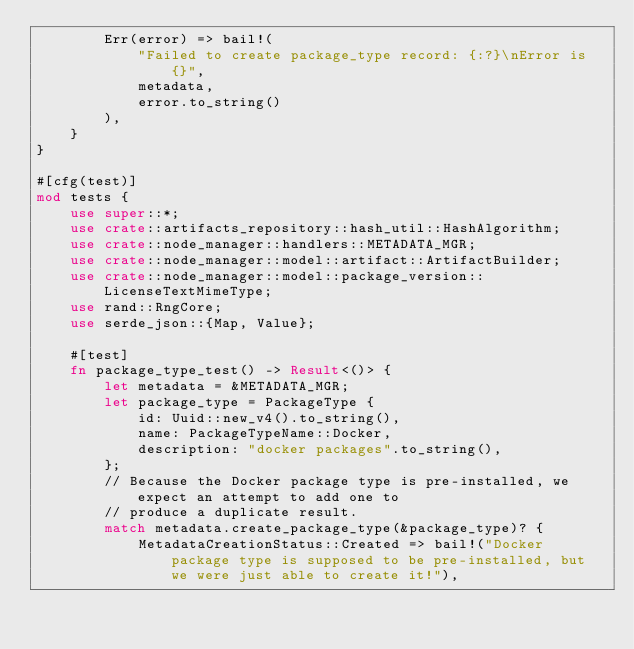Convert code to text. <code><loc_0><loc_0><loc_500><loc_500><_Rust_>        Err(error) => bail!(
            "Failed to create package_type record: {:?}\nError is {}",
            metadata,
            error.to_string()
        ),
    }
}

#[cfg(test)]
mod tests {
    use super::*;
    use crate::artifacts_repository::hash_util::HashAlgorithm;
    use crate::node_manager::handlers::METADATA_MGR;
    use crate::node_manager::model::artifact::ArtifactBuilder;
    use crate::node_manager::model::package_version::LicenseTextMimeType;
    use rand::RngCore;
    use serde_json::{Map, Value};

    #[test]
    fn package_type_test() -> Result<()> {
        let metadata = &METADATA_MGR;
        let package_type = PackageType {
            id: Uuid::new_v4().to_string(),
            name: PackageTypeName::Docker,
            description: "docker packages".to_string(),
        };
        // Because the Docker package type is pre-installed, we expect an attempt to add one to
        // produce a duplicate result.
        match metadata.create_package_type(&package_type)? {
            MetadataCreationStatus::Created => bail!("Docker package type is supposed to be pre-installed, but we were just able to create it!"),</code> 